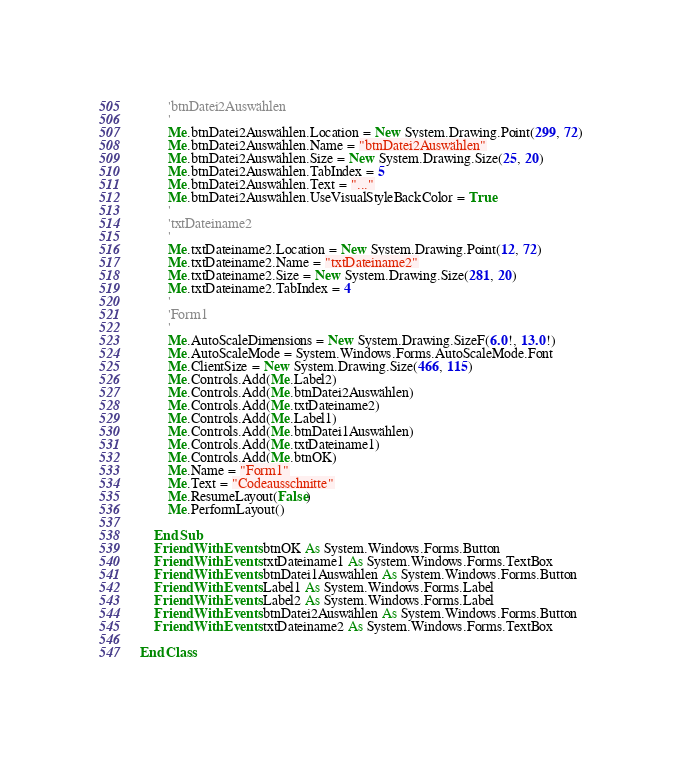<code> <loc_0><loc_0><loc_500><loc_500><_VisualBasic_>        'btnDatei2Auswählen
        '
        Me.btnDatei2Auswählen.Location = New System.Drawing.Point(299, 72)
        Me.btnDatei2Auswählen.Name = "btnDatei2Auswählen"
        Me.btnDatei2Auswählen.Size = New System.Drawing.Size(25, 20)
        Me.btnDatei2Auswählen.TabIndex = 5
        Me.btnDatei2Auswählen.Text = "..."
        Me.btnDatei2Auswählen.UseVisualStyleBackColor = True
        '
        'txtDateiname2
        '
        Me.txtDateiname2.Location = New System.Drawing.Point(12, 72)
        Me.txtDateiname2.Name = "txtDateiname2"
        Me.txtDateiname2.Size = New System.Drawing.Size(281, 20)
        Me.txtDateiname2.TabIndex = 4
        '
        'Form1
        '
        Me.AutoScaleDimensions = New System.Drawing.SizeF(6.0!, 13.0!)
        Me.AutoScaleMode = System.Windows.Forms.AutoScaleMode.Font
        Me.ClientSize = New System.Drawing.Size(466, 115)
        Me.Controls.Add(Me.Label2)
        Me.Controls.Add(Me.btnDatei2Auswählen)
        Me.Controls.Add(Me.txtDateiname2)
        Me.Controls.Add(Me.Label1)
        Me.Controls.Add(Me.btnDatei1Auswählen)
        Me.Controls.Add(Me.txtDateiname1)
        Me.Controls.Add(Me.btnOK)
        Me.Name = "Form1"
        Me.Text = "Codeausschnitte"
        Me.ResumeLayout(False)
        Me.PerformLayout()

    End Sub
    Friend WithEvents btnOK As System.Windows.Forms.Button
    Friend WithEvents txtDateiname1 As System.Windows.Forms.TextBox
    Friend WithEvents btnDatei1Auswählen As System.Windows.Forms.Button
    Friend WithEvents Label1 As System.Windows.Forms.Label
    Friend WithEvents Label2 As System.Windows.Forms.Label
    Friend WithEvents btnDatei2Auswählen As System.Windows.Forms.Button
    Friend WithEvents txtDateiname2 As System.Windows.Forms.TextBox

End Class
</code> 